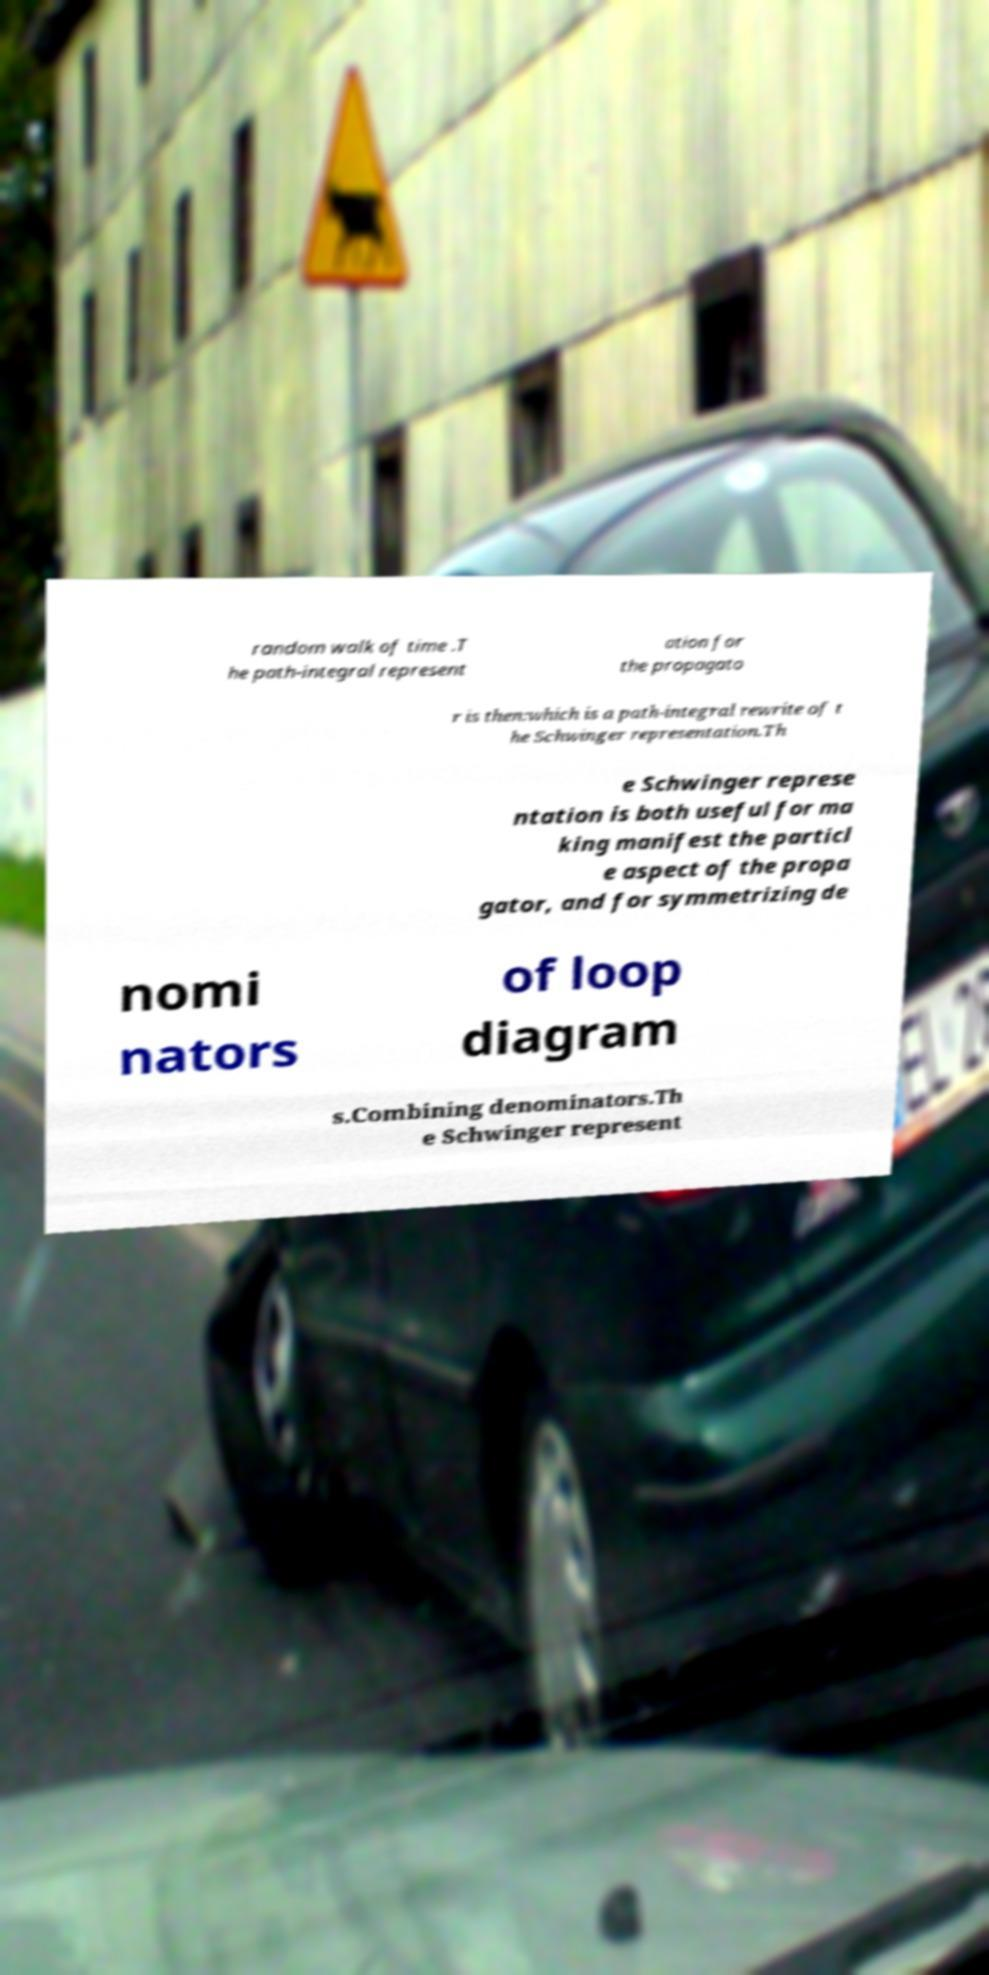Please identify and transcribe the text found in this image. random walk of time .T he path-integral represent ation for the propagato r is then:which is a path-integral rewrite of t he Schwinger representation.Th e Schwinger represe ntation is both useful for ma king manifest the particl e aspect of the propa gator, and for symmetrizing de nomi nators of loop diagram s.Combining denominators.Th e Schwinger represent 